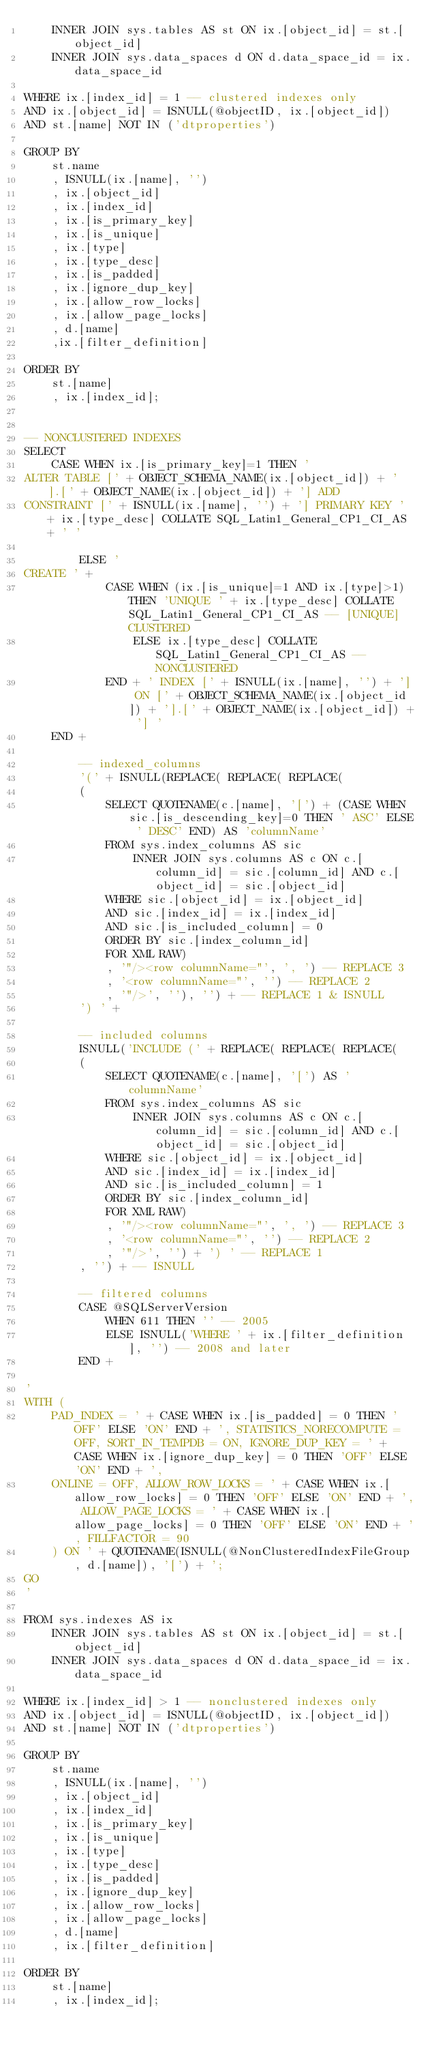<code> <loc_0><loc_0><loc_500><loc_500><_SQL_>    INNER JOIN sys.tables AS st ON ix.[object_id] = st.[object_id]
    INNER JOIN sys.data_spaces d ON d.data_space_id = ix.data_space_id 

WHERE ix.[index_id] = 1 -- clustered indexes only
AND ix.[object_id] = ISNULL(@objectID, ix.[object_id])
AND st.[name] NOT IN ('dtproperties')

GROUP BY 
    st.name
    , ISNULL(ix.[name], '')
    , ix.[object_id]
    , ix.[index_id]
    , ix.[is_primary_key]
    , ix.[is_unique]
    , ix.[type]
    , ix.[type_desc]
    , ix.[is_padded]
    , ix.[ignore_dup_key]
    , ix.[allow_row_locks]
    , ix.[allow_page_locks]
    , d.[name]
    ,ix.[filter_definition]
    
ORDER BY 
    st.[name]
    , ix.[index_id];


-- NONCLUSTERED INDEXES
SELECT 
    CASE WHEN ix.[is_primary_key]=1 THEN '
ALTER TABLE [' + OBJECT_SCHEMA_NAME(ix.[object_id]) + '].[' + OBJECT_NAME(ix.[object_id]) + '] ADD 
CONSTRAINT [' + ISNULL(ix.[name], '') + '] PRIMARY KEY ' + ix.[type_desc] COLLATE SQL_Latin1_General_CP1_CI_AS + ' ' 

        ELSE '
CREATE ' + 
            CASE WHEN (ix.[is_unique]=1 AND ix.[type]>1) THEN 'UNIQUE ' + ix.[type_desc] COLLATE SQL_Latin1_General_CP1_CI_AS -- [UNIQUE] CLUSTERED
                ELSE ix.[type_desc] COLLATE SQL_Latin1_General_CP1_CI_AS -- NONCLUSTERED
            END + ' INDEX [' + ISNULL(ix.[name], '') + '] ON [' + OBJECT_SCHEMA_NAME(ix.[object_id]) + '].[' + OBJECT_NAME(ix.[object_id]) + '] '
    END +

        -- indexed_columns
        '(' + ISNULL(REPLACE( REPLACE( REPLACE(
        (   
            SELECT QUOTENAME(c.[name], '[') + (CASE WHEN sic.[is_descending_key]=0 THEN ' ASC' ELSE ' DESC' END) AS 'columnName'
            FROM sys.index_columns AS sic
                INNER JOIN sys.columns AS c ON c.[column_id] = sic.[column_id] AND c.[object_id] = sic.[object_id]
            WHERE sic.[object_id] = ix.[object_id]
            AND sic.[index_id] = ix.[index_id]
            AND sic.[is_included_column] = 0
            ORDER BY sic.[index_column_id]
            FOR XML RAW)
            , '"/><row columnName="', ', ') -- REPLACE 3
            , '<row columnName="', '') -- REPLACE 2
            , '"/>', ''), '') + -- REPLACE 1 & ISNULL
        ') ' +
        
        -- included columns
        ISNULL('INCLUDE (' + REPLACE( REPLACE( REPLACE(
        (   
            SELECT QUOTENAME(c.[name], '[') AS 'columnName'
            FROM sys.index_columns AS sic
                INNER JOIN sys.columns AS c ON c.[column_id] = sic.[column_id] AND c.[object_id] = sic.[object_id]
            WHERE sic.[object_id] = ix.[object_id]
            AND sic.[index_id] = ix.[index_id]
            AND sic.[is_included_column] = 1
            ORDER BY sic.[index_column_id]
            FOR XML RAW)
            , '"/><row columnName="', ', ') -- REPLACE 3
            , '<row columnName="', '') -- REPLACE 2
            , '"/>', '') + ') ' -- REPLACE 1 
        , '') + -- ISNULL

        -- filtered columns
        CASE @SQLServerVersion
            WHEN 611 THEN '' -- 2005
            ELSE ISNULL('WHERE ' + ix.[filter_definition], '') -- 2008 and later
        END +

'
WITH (
    PAD_INDEX = ' + CASE WHEN ix.[is_padded] = 0 THEN 'OFF' ELSE 'ON' END + ', STATISTICS_NORECOMPUTE = OFF, SORT_IN_TEMPDB = ON, IGNORE_DUP_KEY = ' + CASE WHEN ix.[ignore_dup_key] = 0 THEN 'OFF' ELSE 'ON' END + ', 
    ONLINE = OFF, ALLOW_ROW_LOCKS = ' + CASE WHEN ix.[allow_row_locks] = 0 THEN 'OFF' ELSE 'ON' END + ', ALLOW_PAGE_LOCKS = ' + CASE WHEN ix.[allow_page_locks] = 0 THEN 'OFF' ELSE 'ON' END + ', FILLFACTOR = 90
    ) ON ' + QUOTENAME(ISNULL(@NonClusteredIndexFileGroup, d.[name]), '[') + ';
GO
'

FROM sys.indexes AS ix
    INNER JOIN sys.tables AS st ON ix.[object_id] = st.[object_id]
    INNER JOIN sys.data_spaces d ON d.data_space_id = ix.data_space_id 

WHERE ix.[index_id] > 1 -- nonclustered indexes only
AND ix.[object_id] = ISNULL(@objectID, ix.[object_id])
AND st.[name] NOT IN ('dtproperties')

GROUP BY 
    st.name
    , ISNULL(ix.[name], '')
    , ix.[object_id]
    , ix.[index_id]
    , ix.[is_primary_key]
    , ix.[is_unique]
    , ix.[type]
    , ix.[type_desc]
    , ix.[is_padded]
    , ix.[ignore_dup_key]
    , ix.[allow_row_locks]
    , ix.[allow_page_locks]
    , d.[name]
    , ix.[filter_definition]
    
ORDER BY 
    st.[name]
    , ix.[index_id];

</code> 